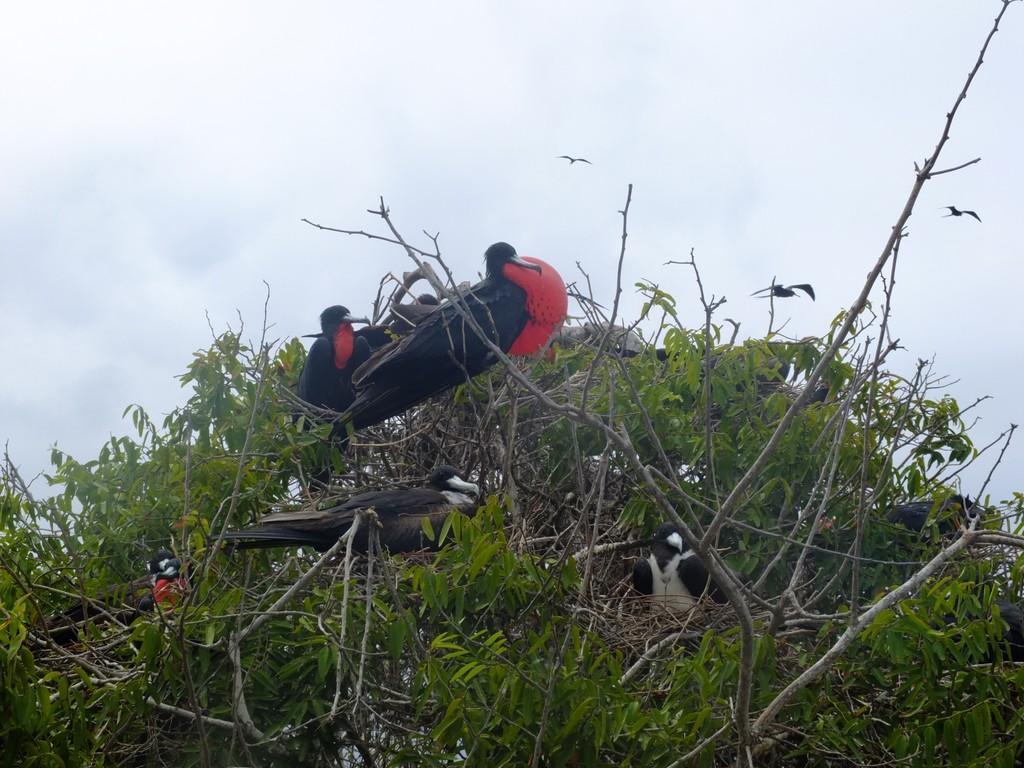How would you summarize this image in a sentence or two? In this image there are birds in the nests on a tree with leaves and branches. 